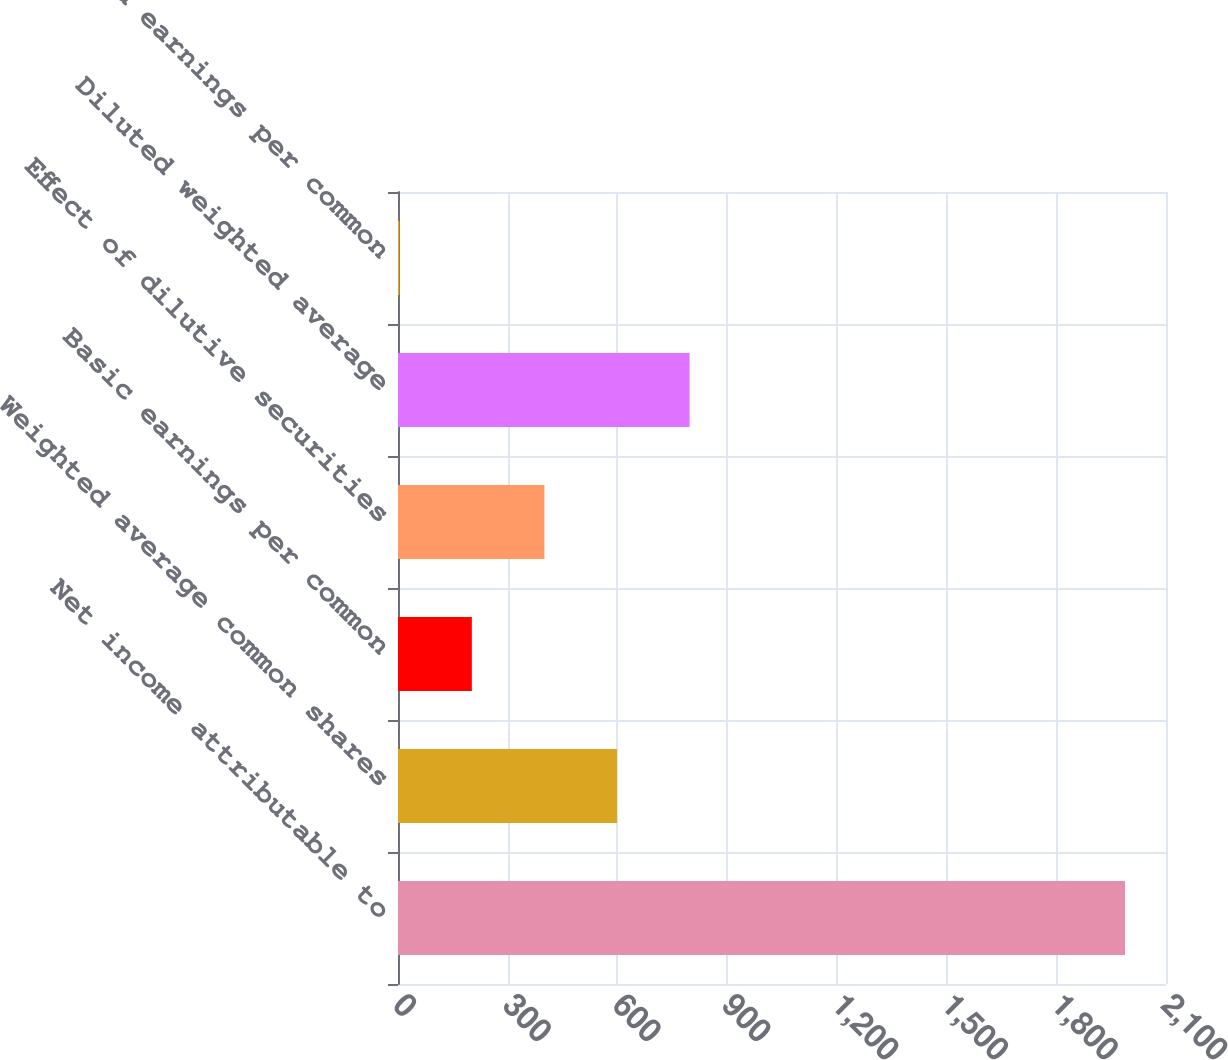Convert chart. <chart><loc_0><loc_0><loc_500><loc_500><bar_chart><fcel>Net income attributable to<fcel>Weighted average common shares<fcel>Basic earnings per common<fcel>Effect of dilutive securities<fcel>Diluted weighted average<fcel>Diluted earnings per common<nl><fcel>1988<fcel>598.81<fcel>201.89<fcel>400.35<fcel>797.27<fcel>3.43<nl></chart> 